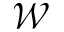<formula> <loc_0><loc_0><loc_500><loc_500>\mathcal { W }</formula> 